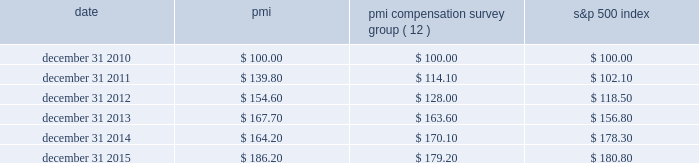Performance graph the graph below compares the cumulative total shareholder return on pmi's common stock with the cumulative total return for the same period of pmi's compensation survey group and the s&p 500 index .
The graph assumes the investment of $ 100 as of december 31 , 2010 , in pmi common stock ( at prices quoted on the new york stock exchange ) and each of the indices as of the market close and reinvestment of dividends on a quarterly basis .
Date pmi pmi compensation survey group ( 12 ) s&p 500 index .
( 1 ) the pmi compensation survey group consists of the following companies with substantial global sales that are direct competitors ; or have similar market capitalization ; or are primarily focused on consumer products ( excluding high technology and financial services ) ; and are companies for which comparative executive compensation data are readily available : bayer ag , british american tobacco p.l.c. , the coca-cola company , diageo plc , glaxosmithkline , heineken n.v. , imperial brands plc ( formerly , imperial tobacco group plc ) , johnson & johnson , mcdonald's corp. , international , inc. , nestl e9 s.a. , novartis ag , pepsico , inc. , pfizer inc. , roche holding ag , unilever nv and plc and vodafone group plc .
( 2 ) on october 1 , 2012 , international , inc .
( nasdaq : mdlz ) , formerly kraft foods inc. , announced that it had completed the spin-off of its north american grocery business , kraft foods group , inc .
( nasdaq : krft ) .
International , inc .
Was retained in the pmi compensation survey group index because of its global footprint .
The pmi compensation survey group index total cumulative return calculation weights international , inc.'s total shareholder return at 65% ( 65 % ) of historical kraft foods inc.'s market capitalization on december 31 , 2010 , based on international , inc.'s initial market capitalization relative to the combined market capitalization of international , inc .
And kraft foods group , inc .
On october 2 , 2012 .
Note : figures are rounded to the nearest $ 0.10. .
What was the percentage cumulative total shareholder return on pmi's common stock for the five years ended december 31 , 2015? 
Computations: ((186.20 - 100) / 100)
Answer: 0.862. 